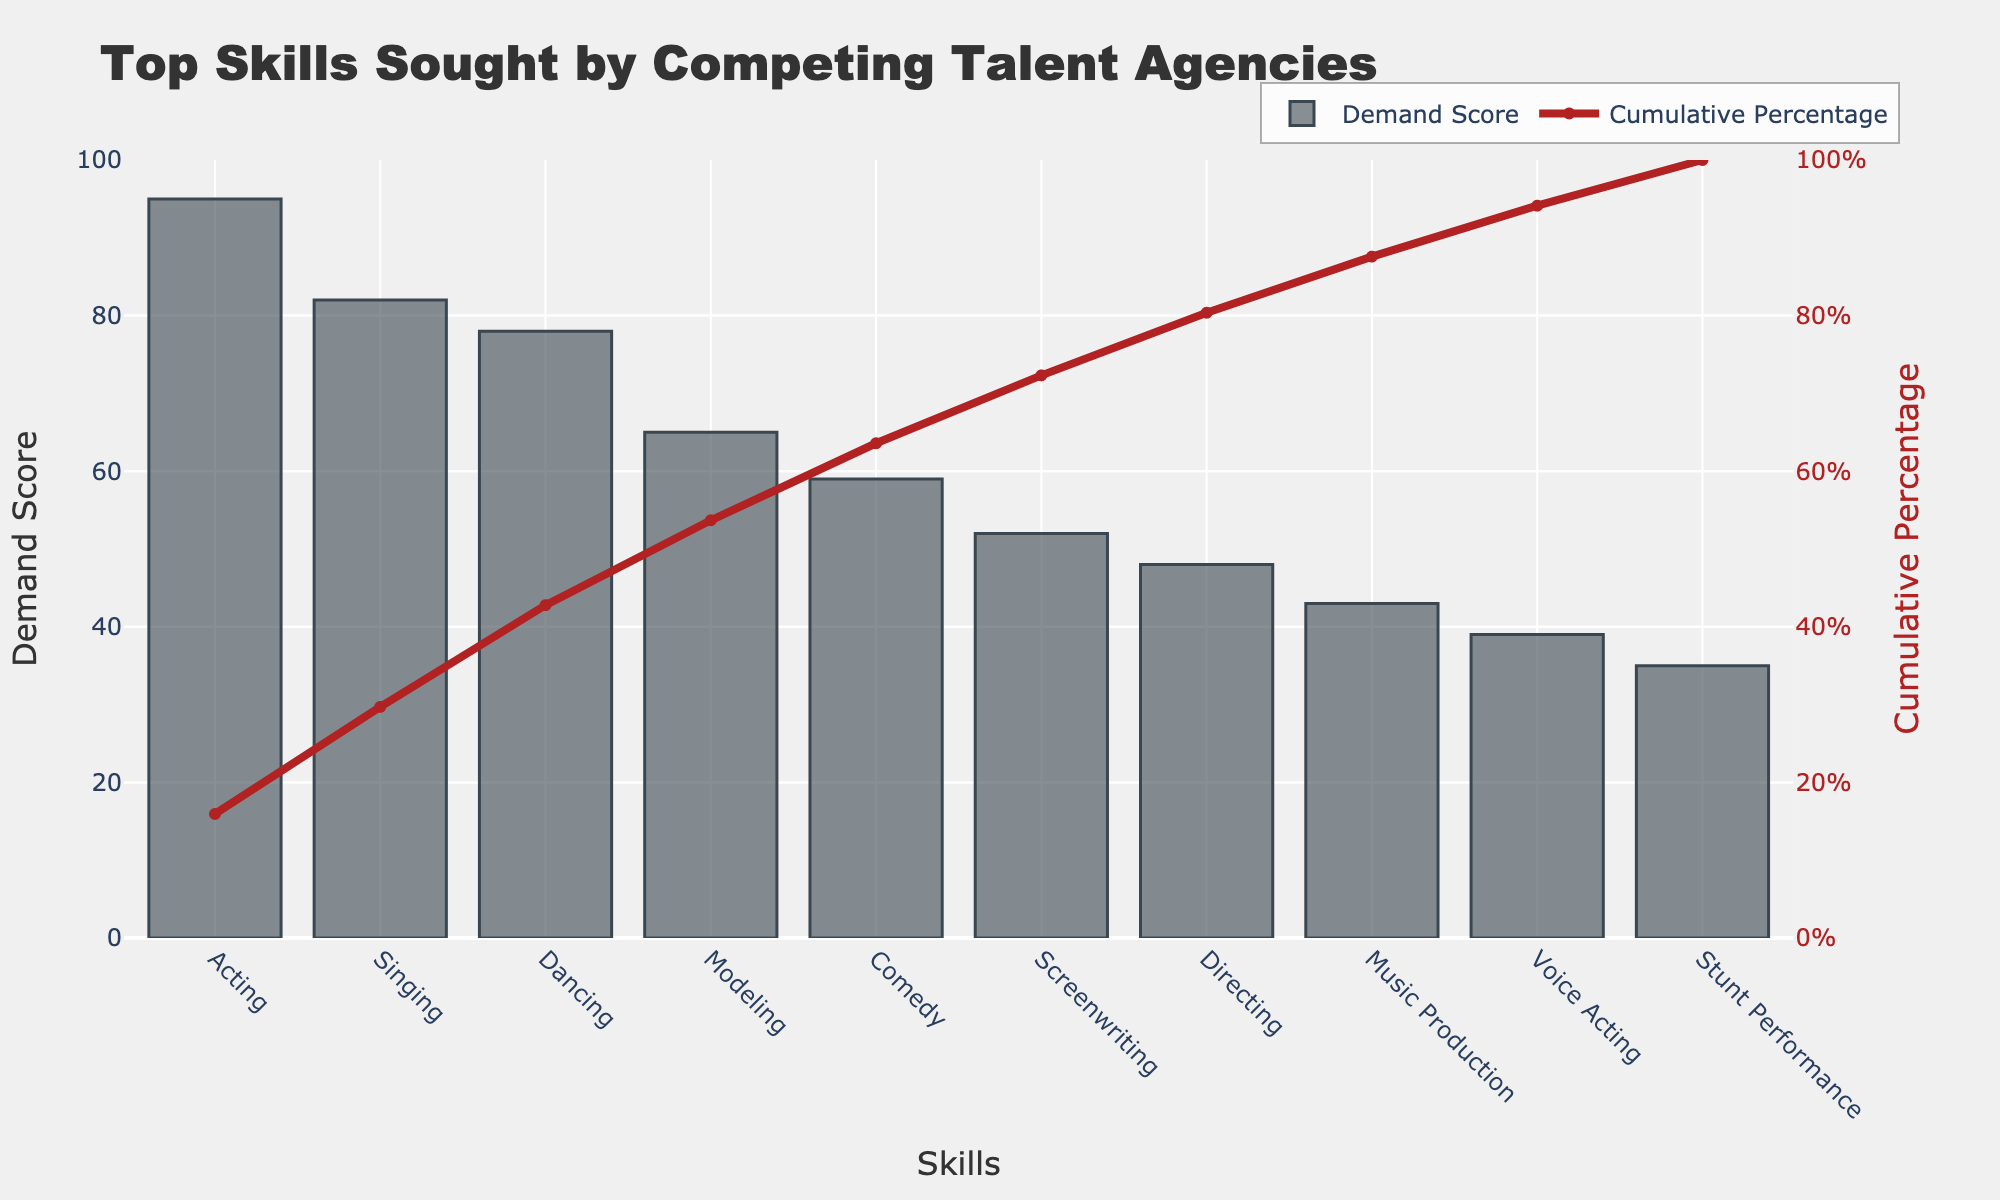What's the title of the chart? The title of the chart is often displayed prominently at the top center of the figure. In this case, you can directly read it off the chart.
Answer: Top Skills Sought by Competing Talent Agencies How many skills are shown in the chart? Count the number of skills listed on the x-axis of the bar chart. Each skill represents a data point.
Answer: 10 Which skill has the highest demand score? Identify the bar with the highest height in the bar chart, which corresponds to the skill with the highest demand score.
Answer: Acting What is the cumulative percentage for Voice Acting? Find the data point labeled "Voice Acting" and trace it to the line chart to read its cumulative percentage.
Answer: 83% What is the difference between the demand score for Singing and Dancing? Identify the demand scores for Singing and Dancing from the bar chart and subtract the smaller score from the larger one.
Answer: 4 Which skill reached the 50% cumulative percentage milestone? Look for the data point on the line chart where the cumulative percentage reaches 50%. Identify the corresponding skill on the x-axis.
Answer: Dancing What is the demand score for Music Production? Find the bar labeled "Music Production" and read its height, which represents the demand score.
Answer: 43 How many skills have a demand score greater than or equal to 50? Identify and count the bars in the chart that have a height corresponding to a demand score of 50 or more.
Answer: 6 What is the combined demand score for the top three skills? Add the demand scores of the top three skills (Acting, Singing, and Dancing) as shown in the bar chart.
Answer: 255 Which has a greater demand score, Comedy or Modeling? Compare the heights of the bars for Comedy and Modeling to see which one is taller.
Answer: Modeling 